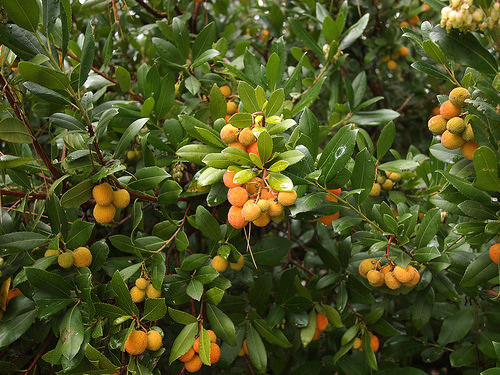<image>
Is there a fruit under the plant? Yes. The fruit is positioned underneath the plant, with the plant above it in the vertical space. 